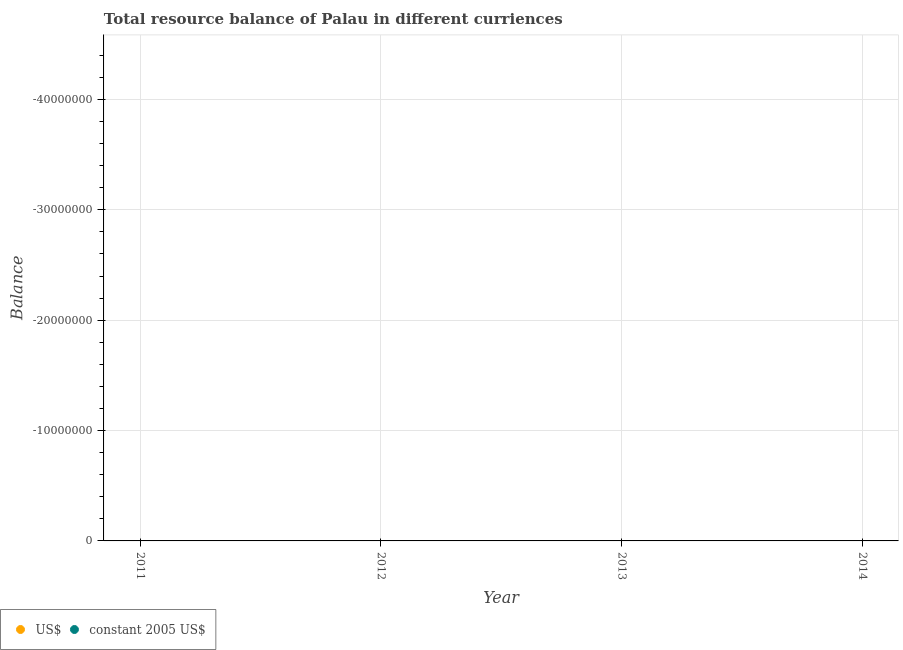Is the number of dotlines equal to the number of legend labels?
Your answer should be very brief. No. Across all years, what is the minimum resource balance in us$?
Offer a very short reply. 0. What is the total resource balance in us$ in the graph?
Make the answer very short. 0. What is the average resource balance in us$ per year?
Your answer should be compact. 0. Does the resource balance in constant us$ monotonically increase over the years?
Offer a terse response. No. Is the resource balance in constant us$ strictly greater than the resource balance in us$ over the years?
Your answer should be very brief. No. Is the resource balance in constant us$ strictly less than the resource balance in us$ over the years?
Make the answer very short. No. How many years are there in the graph?
Make the answer very short. 4. Are the values on the major ticks of Y-axis written in scientific E-notation?
Ensure brevity in your answer.  No. Does the graph contain any zero values?
Your response must be concise. Yes. How many legend labels are there?
Your response must be concise. 2. How are the legend labels stacked?
Offer a very short reply. Horizontal. What is the title of the graph?
Your response must be concise. Total resource balance of Palau in different curriences. What is the label or title of the X-axis?
Make the answer very short. Year. What is the label or title of the Y-axis?
Your answer should be compact. Balance. What is the Balance of US$ in 2011?
Your response must be concise. 0. What is the Balance in US$ in 2012?
Your answer should be compact. 0. What is the Balance of constant 2005 US$ in 2012?
Provide a short and direct response. 0. What is the Balance of US$ in 2013?
Ensure brevity in your answer.  0. What is the Balance in constant 2005 US$ in 2013?
Offer a terse response. 0. 